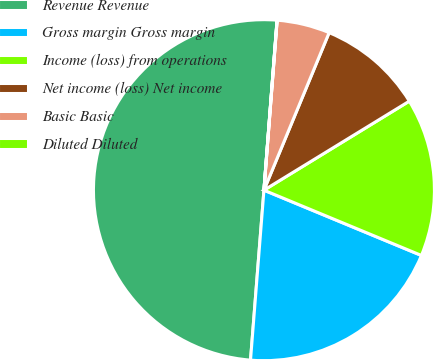<chart> <loc_0><loc_0><loc_500><loc_500><pie_chart><fcel>Revenue Revenue<fcel>Gross margin Gross margin<fcel>Income (loss) from operations<fcel>Net income (loss) Net income<fcel>Basic Basic<fcel>Diluted Diluted<nl><fcel>49.97%<fcel>20.0%<fcel>15.0%<fcel>10.01%<fcel>5.01%<fcel>0.01%<nl></chart> 